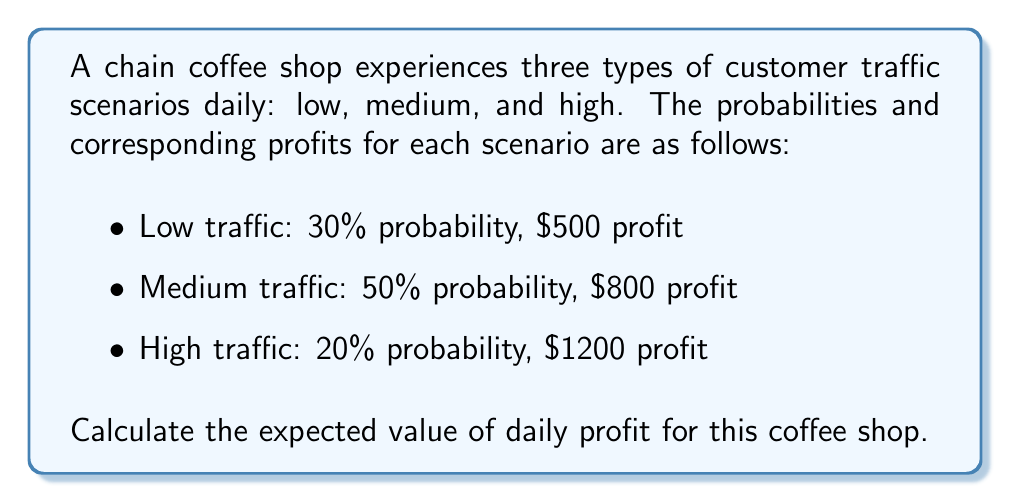Give your solution to this math problem. To calculate the expected value of daily profit, we need to follow these steps:

1. Identify the probability and profit for each scenario:
   - Low traffic: $P(L) = 0.30$, Profit$(L) = \$500$
   - Medium traffic: $P(M) = 0.50$, Profit$(M) = \$800$
   - High traffic: $P(H) = 0.20$, Profit$(H) = \$1200$

2. Calculate the expected value using the formula:
   $$E(\text{Profit}) = \sum_{i} P(i) \cdot \text{Profit}(i)$$
   Where $i$ represents each scenario (Low, Medium, High)

3. Substitute the values into the formula:
   $$E(\text{Profit}) = P(L) \cdot \text{Profit}(L) + P(M) \cdot \text{Profit}(M) + P(H) \cdot \text{Profit}(H)$$

4. Perform the calculations:
   $$E(\text{Profit}) = 0.30 \cdot \$500 + 0.50 \cdot \$800 + 0.20 \cdot \$1200$$
   $$E(\text{Profit}) = \$150 + \$400 + \$240$$
   $$E(\text{Profit}) = \$790$$

Therefore, the expected value of daily profit for this coffee shop is $790.
Answer: $790 